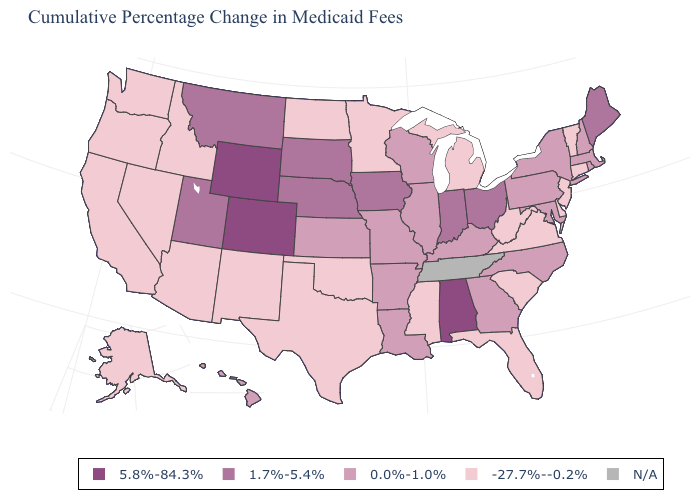What is the lowest value in states that border Pennsylvania?
Quick response, please. -27.7%--0.2%. How many symbols are there in the legend?
Short answer required. 5. What is the value of Oklahoma?
Be succinct. -27.7%--0.2%. What is the value of Montana?
Give a very brief answer. 1.7%-5.4%. Does Indiana have the lowest value in the USA?
Give a very brief answer. No. Name the states that have a value in the range -27.7%--0.2%?
Quick response, please. Alaska, Arizona, California, Connecticut, Delaware, Florida, Idaho, Michigan, Minnesota, Mississippi, Nevada, New Jersey, New Mexico, North Dakota, Oklahoma, Oregon, South Carolina, Texas, Vermont, Virginia, Washington, West Virginia. Which states have the highest value in the USA?
Keep it brief. Alabama, Colorado, Wyoming. What is the highest value in the USA?
Answer briefly. 5.8%-84.3%. Name the states that have a value in the range N/A?
Short answer required. Tennessee. What is the value of Colorado?
Keep it brief. 5.8%-84.3%. What is the value of Maryland?
Keep it brief. 0.0%-1.0%. What is the value of Hawaii?
Write a very short answer. 0.0%-1.0%. Does the first symbol in the legend represent the smallest category?
Short answer required. No. What is the value of New Jersey?
Short answer required. -27.7%--0.2%. 